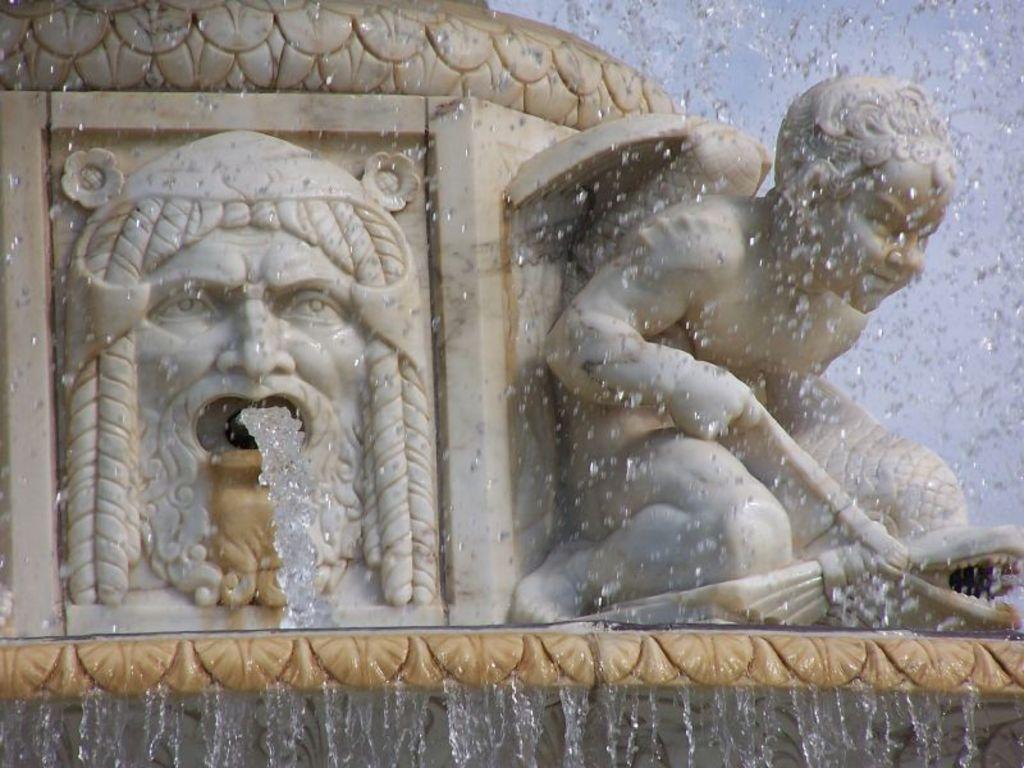How would you summarize this image in a sentence or two? In this image, we can see sculptures releasing water. 